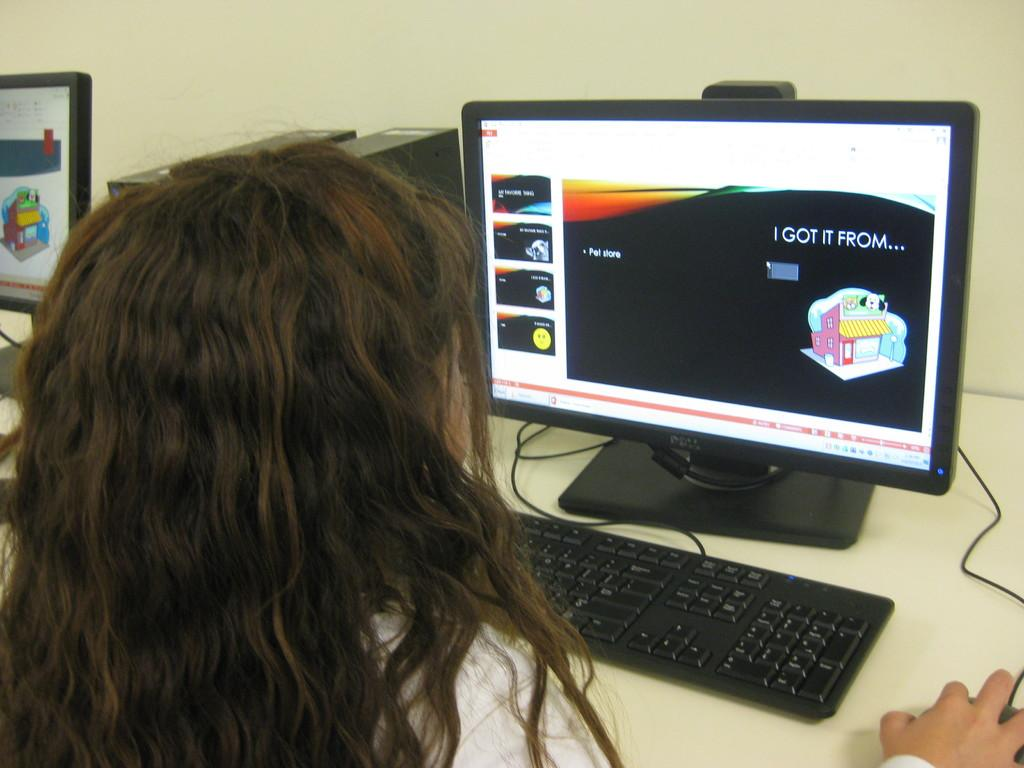Provide a one-sentence caption for the provided image. A woman at a computer with the words 'I got it from' on the screen. 